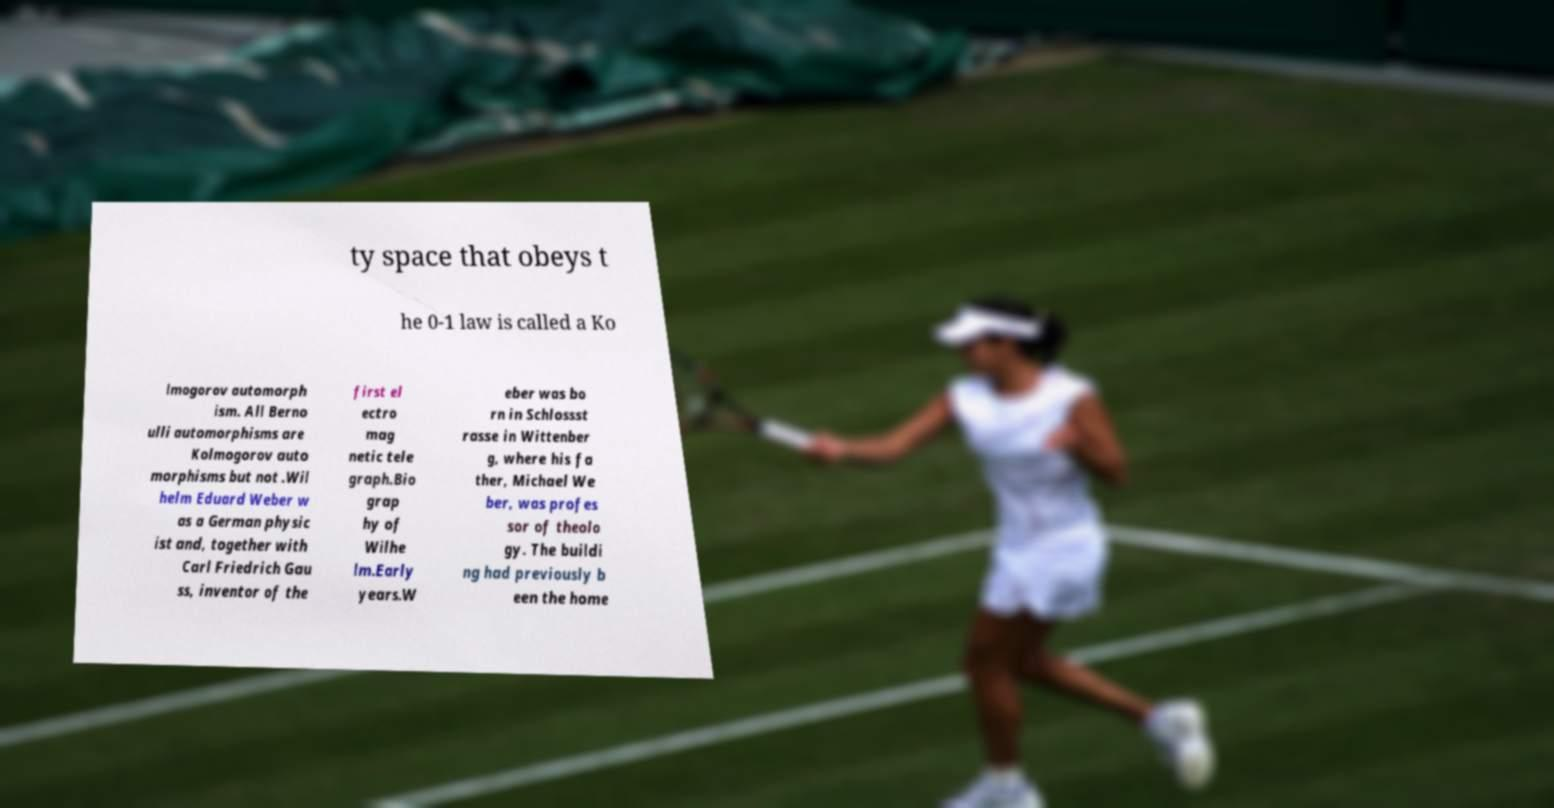Could you assist in decoding the text presented in this image and type it out clearly? ty space that obeys t he 0-1 law is called a Ko lmogorov automorph ism. All Berno ulli automorphisms are Kolmogorov auto morphisms but not .Wil helm Eduard Weber w as a German physic ist and, together with Carl Friedrich Gau ss, inventor of the first el ectro mag netic tele graph.Bio grap hy of Wilhe lm.Early years.W eber was bo rn in Schlossst rasse in Wittenber g, where his fa ther, Michael We ber, was profes sor of theolo gy. The buildi ng had previously b een the home 